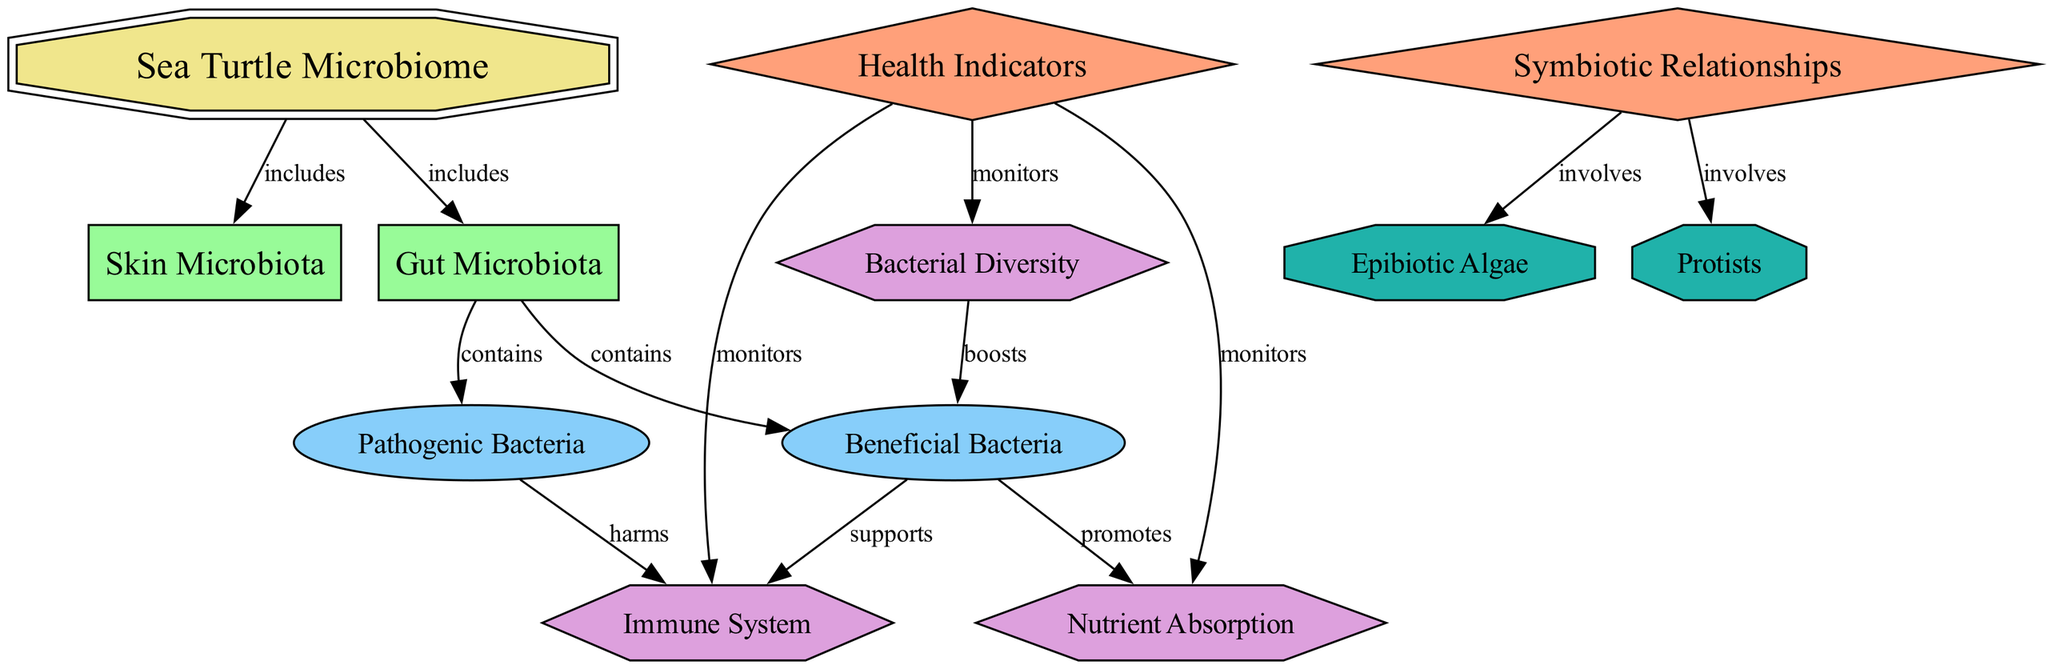What is the central node in the diagram? The central node is identified as the "Sea Turtle Microbiome." It is the main focus of the diagram and serves as the hub from which all other nodes are connected.
Answer: Sea Turtle Microbiome How many components are included in the sea turtle microbiome? The diagram indicates that there are two components: "Gut Microbiota" and "Skin Microbiota." These are explicitly mentioned as parts of the central node.
Answer: 2 Which type of microbiota contains beneficial bacteria? The "Gut Microbiota" is indicated as the component that contains beneficial bacteria, as it has a direct edge connecting it to the "Beneficial Bacteria" node, establishing this relationship.
Answer: Gut Microbiota What does the "Health Indicators" category monitor? The "Health Indicators" category monitors three indicators: "Nutrient Absorption," "Immune System," and "Bacterial Diversity." This is shown through edges connecting the category to each of the indicators.
Answer: Nutrient Absorption, Immune System, Bacterial Diversity How does beneficial bacteria support the immune system? The diagram indicates that beneficial bacteria support the immune system through a direct edge that connects "Beneficial Bacteria" to "Immune System," illustrating this positive relationship.
Answer: Supports What is involved in the symbiotic relationships as per the diagram? The symbiotic relationships involve "Epibiotic Algae" and "Protists," as shown by the edges stemming from the "Symbiotic Relationships" category toward these two symbionts.
Answer: Epibiotic Algae, Protists What harmful effect do pathogenic bacteria have? The diagram indicates that pathogenic bacteria harm the immune system, as there is a direct connection from "Pathogenic Bacteria" to "Immune System," establishing this negative relationship.
Answer: Harms How does bacterial diversity boost beneficial bacteria? The diagram shows that bacterial diversity boosts beneficial bacteria by the direct edge between the "Bacterial Diversity" indicator and "Beneficial Bacteria," illustrating that greater diversity leads to better bacterial health.
Answer: Boosts Which category involves the relationships between organisms in the microbiome? The category that involves the relationships between organisms in the microbiome is "Symbiotic Relationships." This node connects to symbionts, highlighting interactions within the microbiome.
Answer: Symbiotic Relationships 